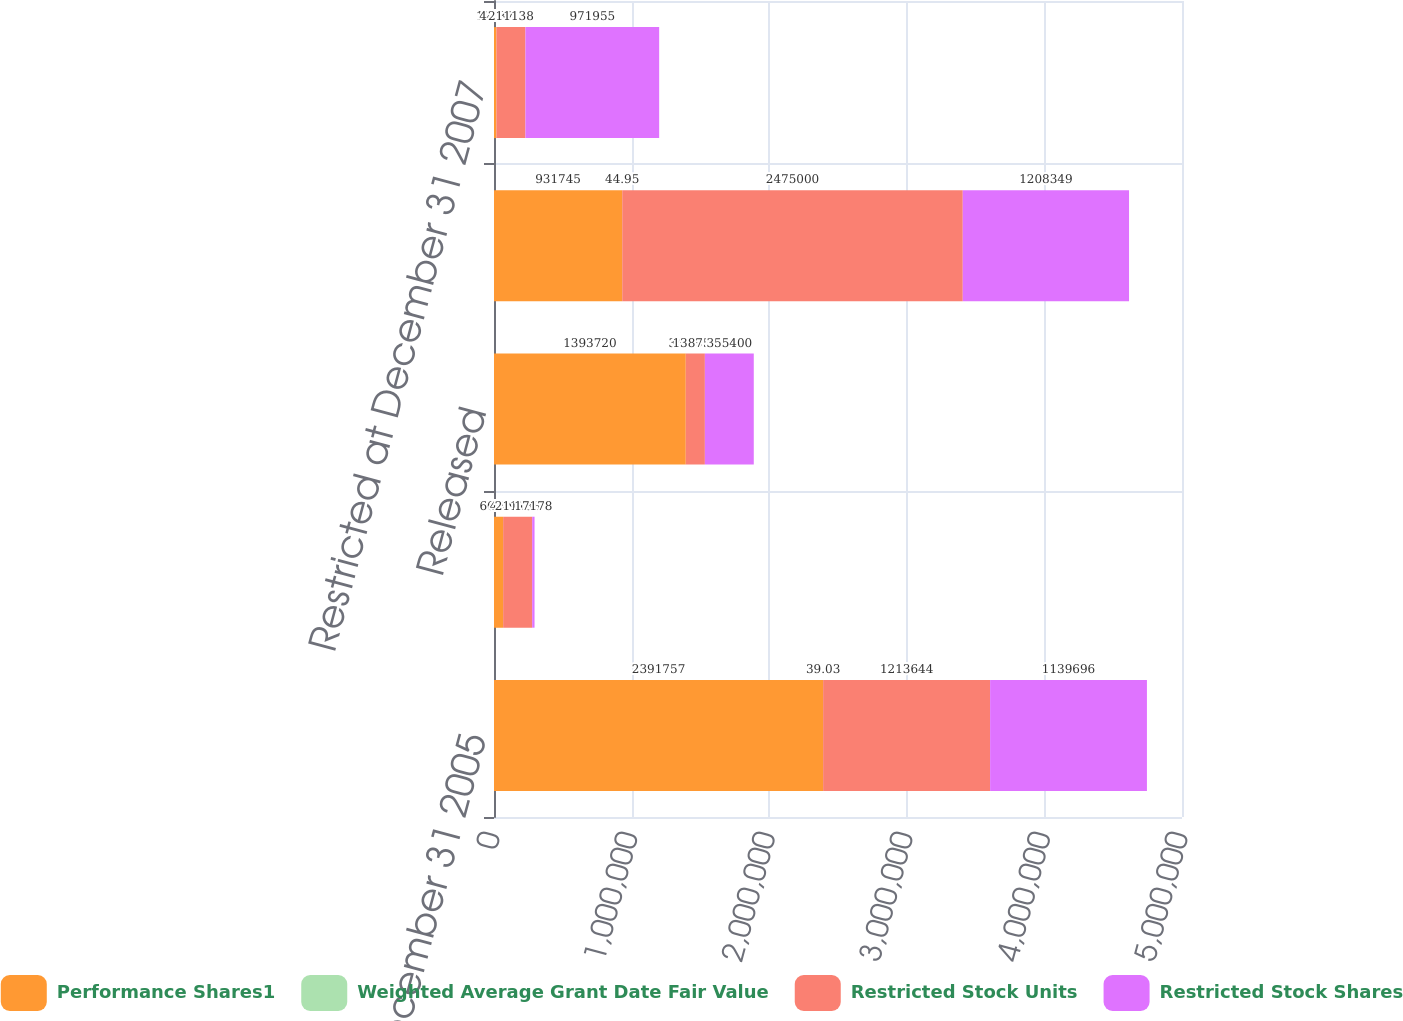Convert chart. <chart><loc_0><loc_0><loc_500><loc_500><stacked_bar_chart><ecel><fcel>Restricted at December 31 2005<fcel>Forfeited<fcel>Released<fcel>Restricted at December 31 2006<fcel>Restricted at December 31 2007<nl><fcel>Performance Shares1<fcel>2.39176e+06<fcel>66292<fcel>1.39372e+06<fcel>931745<fcel>17158<nl><fcel>Weighted Average Grant Date Fair Value<fcel>39.03<fcel>44.9<fcel>34.89<fcel>44.95<fcel>44.37<nl><fcel>Restricted Stock Units<fcel>1.21364e+06<fcel>211138<fcel>138751<fcel>2.475e+06<fcel>211138<nl><fcel>Restricted Stock Shares<fcel>1.1397e+06<fcel>17178<fcel>355400<fcel>1.20835e+06<fcel>971955<nl></chart> 